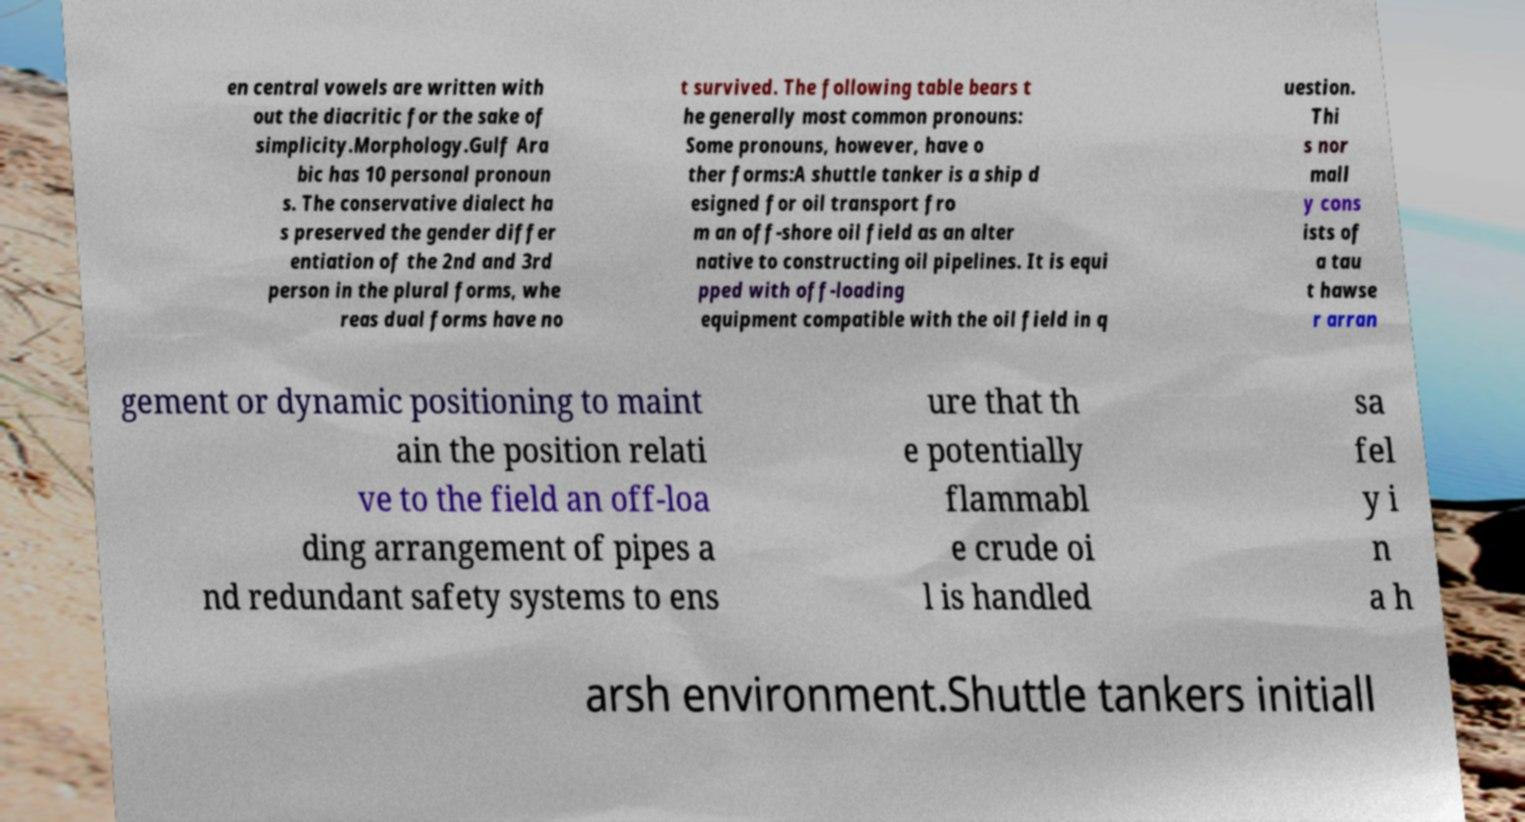Could you assist in decoding the text presented in this image and type it out clearly? en central vowels are written with out the diacritic for the sake of simplicity.Morphology.Gulf Ara bic has 10 personal pronoun s. The conservative dialect ha s preserved the gender differ entiation of the 2nd and 3rd person in the plural forms, whe reas dual forms have no t survived. The following table bears t he generally most common pronouns: Some pronouns, however, have o ther forms:A shuttle tanker is a ship d esigned for oil transport fro m an off-shore oil field as an alter native to constructing oil pipelines. It is equi pped with off-loading equipment compatible with the oil field in q uestion. Thi s nor mall y cons ists of a tau t hawse r arran gement or dynamic positioning to maint ain the position relati ve to the field an off-loa ding arrangement of pipes a nd redundant safety systems to ens ure that th e potentially flammabl e crude oi l is handled sa fel y i n a h arsh environment.Shuttle tankers initiall 